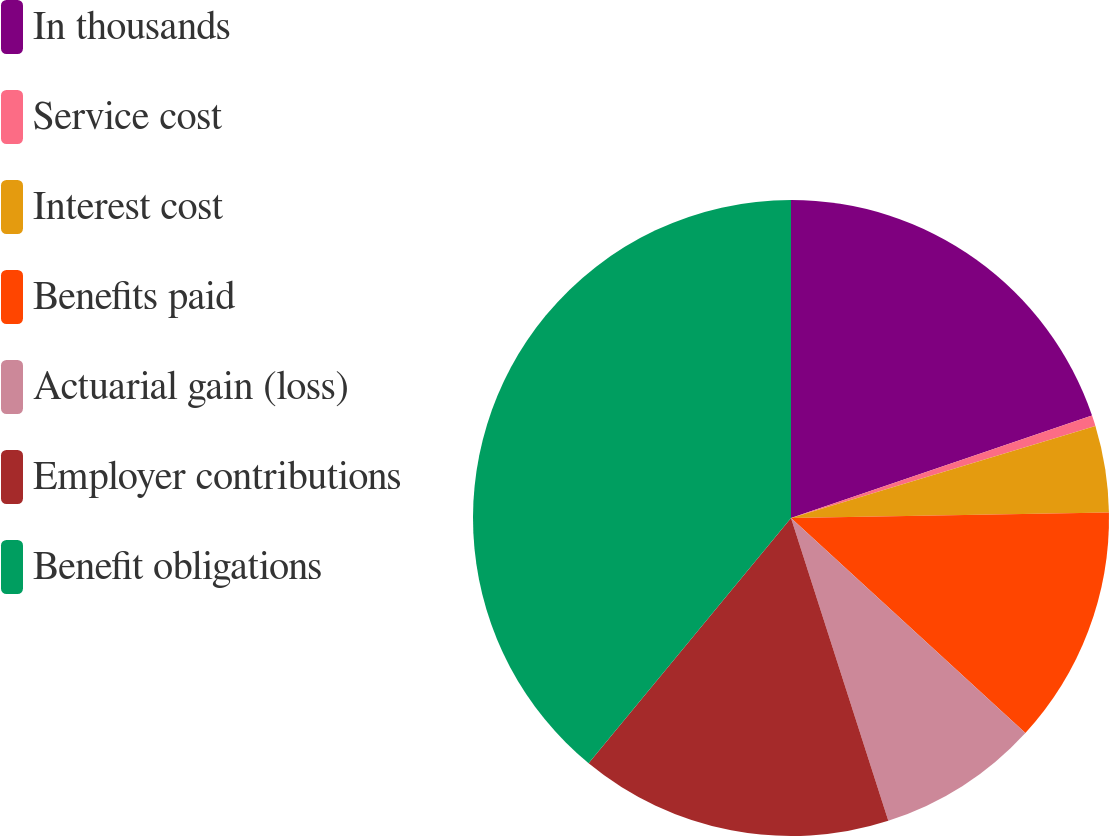Convert chart. <chart><loc_0><loc_0><loc_500><loc_500><pie_chart><fcel>In thousands<fcel>Service cost<fcel>Interest cost<fcel>Benefits paid<fcel>Actuarial gain (loss)<fcel>Employer contributions<fcel>Benefit obligations<nl><fcel>19.78%<fcel>0.55%<fcel>4.39%<fcel>12.09%<fcel>8.24%<fcel>15.93%<fcel>39.02%<nl></chart> 